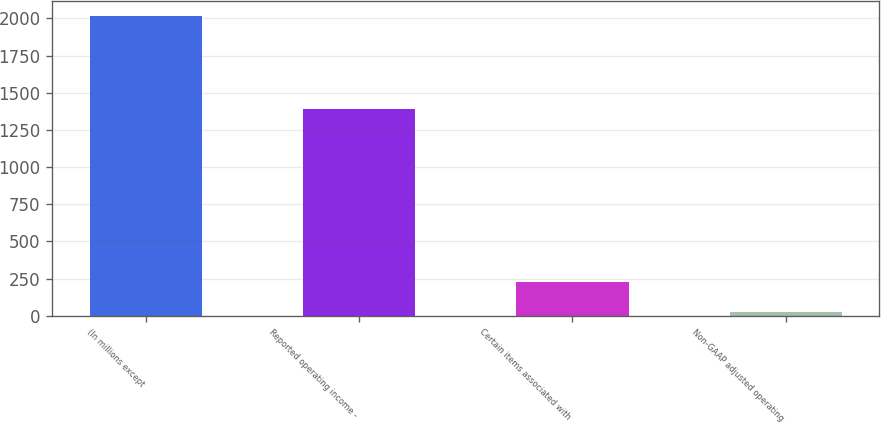Convert chart. <chart><loc_0><loc_0><loc_500><loc_500><bar_chart><fcel>(In millions except<fcel>Reported operating income -<fcel>Certain items associated with<fcel>Non-GAAP adjusted operating<nl><fcel>2014<fcel>1391<fcel>224.98<fcel>26.2<nl></chart> 